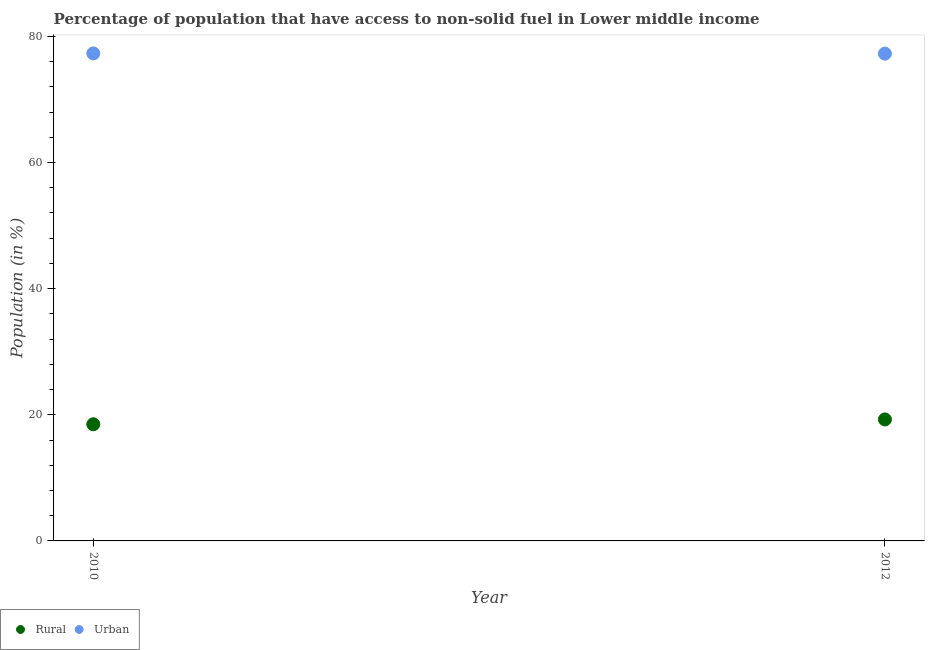How many different coloured dotlines are there?
Offer a very short reply. 2. What is the urban population in 2010?
Offer a terse response. 77.29. Across all years, what is the maximum rural population?
Make the answer very short. 19.26. Across all years, what is the minimum urban population?
Your answer should be compact. 77.26. In which year was the urban population minimum?
Provide a succinct answer. 2012. What is the total urban population in the graph?
Give a very brief answer. 154.55. What is the difference between the urban population in 2010 and that in 2012?
Offer a very short reply. 0.04. What is the difference between the urban population in 2010 and the rural population in 2012?
Your answer should be compact. 58.03. What is the average rural population per year?
Provide a succinct answer. 18.88. In the year 2010, what is the difference between the rural population and urban population?
Provide a short and direct response. -58.8. In how many years, is the urban population greater than 4 %?
Your response must be concise. 2. What is the ratio of the rural population in 2010 to that in 2012?
Offer a very short reply. 0.96. Is the rural population in 2010 less than that in 2012?
Your response must be concise. Yes. What is the difference between two consecutive major ticks on the Y-axis?
Provide a succinct answer. 20. Does the graph contain grids?
Your answer should be compact. No. How are the legend labels stacked?
Offer a very short reply. Horizontal. What is the title of the graph?
Your answer should be compact. Percentage of population that have access to non-solid fuel in Lower middle income. What is the label or title of the X-axis?
Make the answer very short. Year. What is the label or title of the Y-axis?
Your answer should be very brief. Population (in %). What is the Population (in %) of Rural in 2010?
Provide a succinct answer. 18.5. What is the Population (in %) in Urban in 2010?
Keep it short and to the point. 77.29. What is the Population (in %) in Rural in 2012?
Your response must be concise. 19.26. What is the Population (in %) in Urban in 2012?
Provide a succinct answer. 77.26. Across all years, what is the maximum Population (in %) of Rural?
Ensure brevity in your answer.  19.26. Across all years, what is the maximum Population (in %) in Urban?
Make the answer very short. 77.29. Across all years, what is the minimum Population (in %) in Rural?
Make the answer very short. 18.5. Across all years, what is the minimum Population (in %) in Urban?
Your answer should be very brief. 77.26. What is the total Population (in %) of Rural in the graph?
Provide a short and direct response. 37.76. What is the total Population (in %) in Urban in the graph?
Keep it short and to the point. 154.55. What is the difference between the Population (in %) in Rural in 2010 and that in 2012?
Make the answer very short. -0.76. What is the difference between the Population (in %) in Urban in 2010 and that in 2012?
Provide a succinct answer. 0.04. What is the difference between the Population (in %) of Rural in 2010 and the Population (in %) of Urban in 2012?
Your answer should be compact. -58.76. What is the average Population (in %) in Rural per year?
Your answer should be very brief. 18.88. What is the average Population (in %) of Urban per year?
Provide a succinct answer. 77.28. In the year 2010, what is the difference between the Population (in %) of Rural and Population (in %) of Urban?
Keep it short and to the point. -58.8. In the year 2012, what is the difference between the Population (in %) in Rural and Population (in %) in Urban?
Your response must be concise. -58. What is the ratio of the Population (in %) of Rural in 2010 to that in 2012?
Make the answer very short. 0.96. What is the ratio of the Population (in %) in Urban in 2010 to that in 2012?
Provide a short and direct response. 1. What is the difference between the highest and the second highest Population (in %) of Rural?
Offer a terse response. 0.76. What is the difference between the highest and the second highest Population (in %) of Urban?
Provide a succinct answer. 0.04. What is the difference between the highest and the lowest Population (in %) of Rural?
Your answer should be compact. 0.76. What is the difference between the highest and the lowest Population (in %) of Urban?
Offer a very short reply. 0.04. 